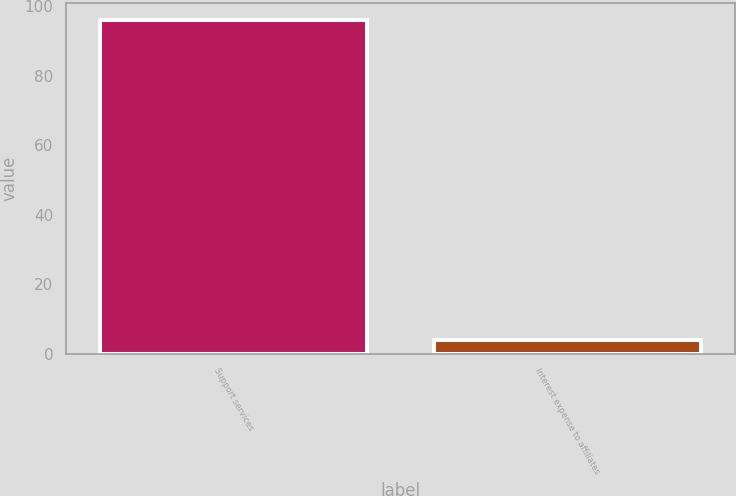<chart> <loc_0><loc_0><loc_500><loc_500><bar_chart><fcel>Support services<fcel>Interest expense to affiliates<nl><fcel>96<fcel>4<nl></chart> 